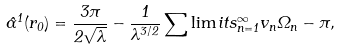<formula> <loc_0><loc_0><loc_500><loc_500>\hat { \alpha } ^ { 1 } ( r _ { 0 } ) = \frac { 3 \pi } { 2 \sqrt { \lambda } } - \frac { 1 } { \lambda ^ { 3 / 2 } } \sum \lim i t s _ { n = 1 } ^ { \infty } { v _ { n } \Omega _ { n } } - \pi ,</formula> 